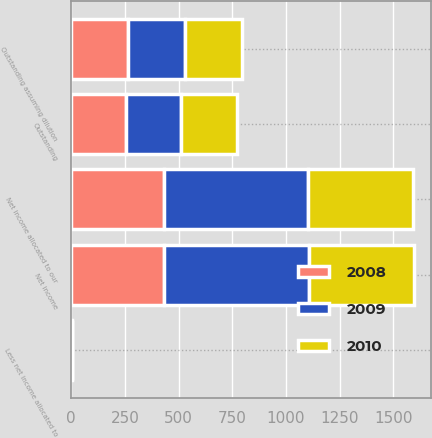<chart> <loc_0><loc_0><loc_500><loc_500><stacked_bar_chart><ecel><fcel>Net income<fcel>Less net income allocated to<fcel>Net income allocated to our<fcel>Outstanding<fcel>Outstanding assuming dilution<nl><fcel>2010<fcel>490.8<fcel>1.1<fcel>489.7<fcel>259.3<fcel>269.9<nl><fcel>2008<fcel>433.6<fcel>1.5<fcel>432.1<fcel>255.9<fcel>262.3<nl><fcel>2009<fcel>672.2<fcel>2.8<fcel>669.4<fcel>257.2<fcel>265.1<nl></chart> 